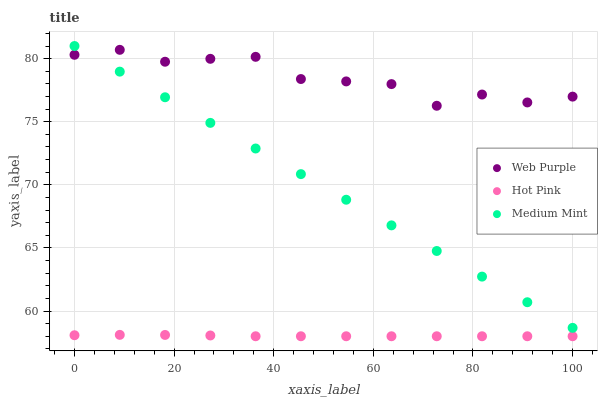Does Hot Pink have the minimum area under the curve?
Answer yes or no. Yes. Does Web Purple have the maximum area under the curve?
Answer yes or no. Yes. Does Web Purple have the minimum area under the curve?
Answer yes or no. No. Does Hot Pink have the maximum area under the curve?
Answer yes or no. No. Is Medium Mint the smoothest?
Answer yes or no. Yes. Is Web Purple the roughest?
Answer yes or no. Yes. Is Hot Pink the smoothest?
Answer yes or no. No. Is Hot Pink the roughest?
Answer yes or no. No. Does Hot Pink have the lowest value?
Answer yes or no. Yes. Does Web Purple have the lowest value?
Answer yes or no. No. Does Medium Mint have the highest value?
Answer yes or no. Yes. Does Web Purple have the highest value?
Answer yes or no. No. Is Hot Pink less than Medium Mint?
Answer yes or no. Yes. Is Web Purple greater than Hot Pink?
Answer yes or no. Yes. Does Web Purple intersect Medium Mint?
Answer yes or no. Yes. Is Web Purple less than Medium Mint?
Answer yes or no. No. Is Web Purple greater than Medium Mint?
Answer yes or no. No. Does Hot Pink intersect Medium Mint?
Answer yes or no. No. 